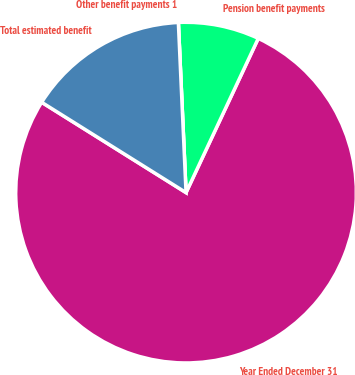Convert chart to OTSL. <chart><loc_0><loc_0><loc_500><loc_500><pie_chart><fcel>Year Ended December 31<fcel>Pension benefit payments<fcel>Other benefit payments 1<fcel>Total estimated benefit<nl><fcel>76.92%<fcel>7.69%<fcel>0.0%<fcel>15.38%<nl></chart> 